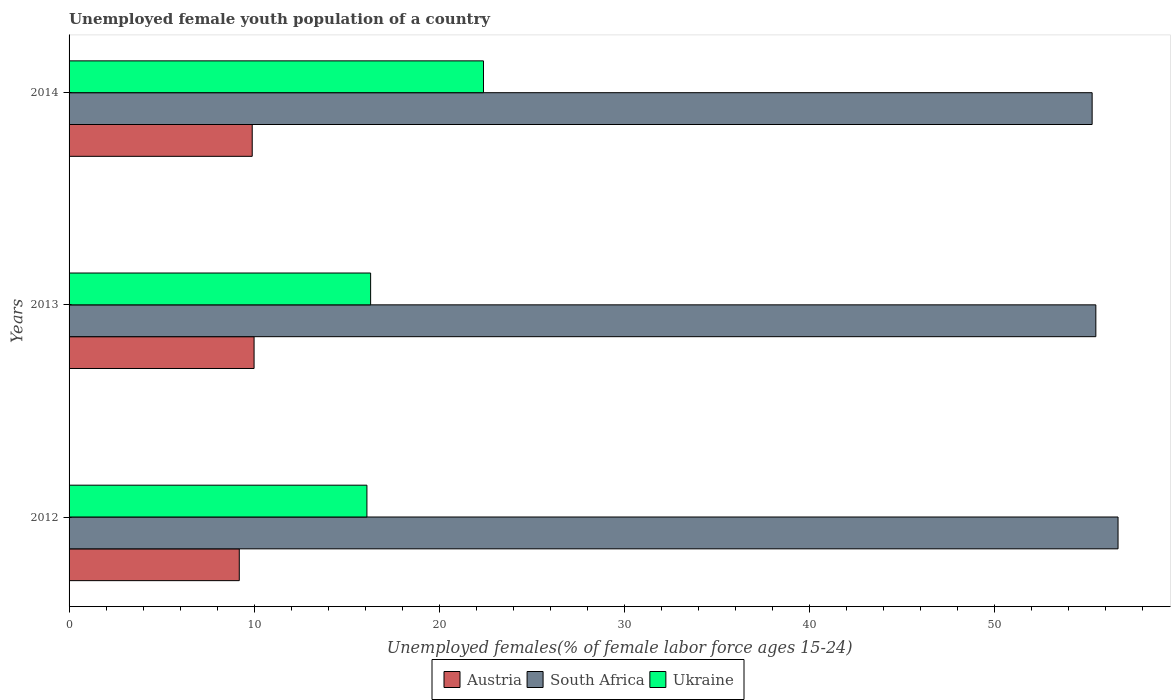Are the number of bars per tick equal to the number of legend labels?
Your answer should be very brief. Yes. Are the number of bars on each tick of the Y-axis equal?
Provide a succinct answer. Yes. What is the label of the 3rd group of bars from the top?
Your answer should be very brief. 2012. What is the percentage of unemployed female youth population in Austria in 2014?
Provide a succinct answer. 9.9. Across all years, what is the maximum percentage of unemployed female youth population in South Africa?
Ensure brevity in your answer.  56.7. Across all years, what is the minimum percentage of unemployed female youth population in Austria?
Keep it short and to the point. 9.2. In which year was the percentage of unemployed female youth population in South Africa minimum?
Your response must be concise. 2014. What is the total percentage of unemployed female youth population in Ukraine in the graph?
Your answer should be very brief. 54.8. What is the difference between the percentage of unemployed female youth population in South Africa in 2012 and that in 2014?
Offer a terse response. 1.4. What is the difference between the percentage of unemployed female youth population in Austria in 2014 and the percentage of unemployed female youth population in Ukraine in 2012?
Ensure brevity in your answer.  -6.2. What is the average percentage of unemployed female youth population in Ukraine per year?
Make the answer very short. 18.27. In the year 2012, what is the difference between the percentage of unemployed female youth population in South Africa and percentage of unemployed female youth population in Austria?
Give a very brief answer. 47.5. What is the ratio of the percentage of unemployed female youth population in Ukraine in 2012 to that in 2013?
Keep it short and to the point. 0.99. Is the percentage of unemployed female youth population in South Africa in 2012 less than that in 2013?
Ensure brevity in your answer.  No. Is the difference between the percentage of unemployed female youth population in South Africa in 2012 and 2013 greater than the difference between the percentage of unemployed female youth population in Austria in 2012 and 2013?
Your answer should be very brief. Yes. What is the difference between the highest and the second highest percentage of unemployed female youth population in Ukraine?
Ensure brevity in your answer.  6.1. What is the difference between the highest and the lowest percentage of unemployed female youth population in South Africa?
Provide a short and direct response. 1.4. In how many years, is the percentage of unemployed female youth population in Ukraine greater than the average percentage of unemployed female youth population in Ukraine taken over all years?
Offer a terse response. 1. Is the sum of the percentage of unemployed female youth population in South Africa in 2012 and 2013 greater than the maximum percentage of unemployed female youth population in Ukraine across all years?
Your answer should be very brief. Yes. What does the 2nd bar from the top in 2013 represents?
Offer a very short reply. South Africa. What does the 1st bar from the bottom in 2012 represents?
Give a very brief answer. Austria. How many bars are there?
Offer a very short reply. 9. Are all the bars in the graph horizontal?
Your response must be concise. Yes. What is the difference between two consecutive major ticks on the X-axis?
Make the answer very short. 10. Are the values on the major ticks of X-axis written in scientific E-notation?
Keep it short and to the point. No. Does the graph contain grids?
Provide a succinct answer. No. How many legend labels are there?
Your response must be concise. 3. How are the legend labels stacked?
Give a very brief answer. Horizontal. What is the title of the graph?
Provide a short and direct response. Unemployed female youth population of a country. What is the label or title of the X-axis?
Offer a terse response. Unemployed females(% of female labor force ages 15-24). What is the label or title of the Y-axis?
Your answer should be very brief. Years. What is the Unemployed females(% of female labor force ages 15-24) of Austria in 2012?
Make the answer very short. 9.2. What is the Unemployed females(% of female labor force ages 15-24) in South Africa in 2012?
Provide a succinct answer. 56.7. What is the Unemployed females(% of female labor force ages 15-24) in Ukraine in 2012?
Your answer should be very brief. 16.1. What is the Unemployed females(% of female labor force ages 15-24) of South Africa in 2013?
Provide a succinct answer. 55.5. What is the Unemployed females(% of female labor force ages 15-24) of Ukraine in 2013?
Provide a short and direct response. 16.3. What is the Unemployed females(% of female labor force ages 15-24) of Austria in 2014?
Make the answer very short. 9.9. What is the Unemployed females(% of female labor force ages 15-24) of South Africa in 2014?
Keep it short and to the point. 55.3. What is the Unemployed females(% of female labor force ages 15-24) in Ukraine in 2014?
Offer a terse response. 22.4. Across all years, what is the maximum Unemployed females(% of female labor force ages 15-24) of South Africa?
Ensure brevity in your answer.  56.7. Across all years, what is the maximum Unemployed females(% of female labor force ages 15-24) of Ukraine?
Provide a short and direct response. 22.4. Across all years, what is the minimum Unemployed females(% of female labor force ages 15-24) of Austria?
Ensure brevity in your answer.  9.2. Across all years, what is the minimum Unemployed females(% of female labor force ages 15-24) of South Africa?
Your response must be concise. 55.3. Across all years, what is the minimum Unemployed females(% of female labor force ages 15-24) of Ukraine?
Offer a very short reply. 16.1. What is the total Unemployed females(% of female labor force ages 15-24) of Austria in the graph?
Your response must be concise. 29.1. What is the total Unemployed females(% of female labor force ages 15-24) in South Africa in the graph?
Your response must be concise. 167.5. What is the total Unemployed females(% of female labor force ages 15-24) of Ukraine in the graph?
Provide a succinct answer. 54.8. What is the difference between the Unemployed females(% of female labor force ages 15-24) in South Africa in 2012 and that in 2013?
Keep it short and to the point. 1.2. What is the difference between the Unemployed females(% of female labor force ages 15-24) in Ukraine in 2012 and that in 2013?
Provide a short and direct response. -0.2. What is the difference between the Unemployed females(% of female labor force ages 15-24) of Ukraine in 2012 and that in 2014?
Make the answer very short. -6.3. What is the difference between the Unemployed females(% of female labor force ages 15-24) of Austria in 2013 and that in 2014?
Ensure brevity in your answer.  0.1. What is the difference between the Unemployed females(% of female labor force ages 15-24) of South Africa in 2013 and that in 2014?
Your response must be concise. 0.2. What is the difference between the Unemployed females(% of female labor force ages 15-24) in Ukraine in 2013 and that in 2014?
Provide a succinct answer. -6.1. What is the difference between the Unemployed females(% of female labor force ages 15-24) in Austria in 2012 and the Unemployed females(% of female labor force ages 15-24) in South Africa in 2013?
Offer a terse response. -46.3. What is the difference between the Unemployed females(% of female labor force ages 15-24) of Austria in 2012 and the Unemployed females(% of female labor force ages 15-24) of Ukraine in 2013?
Your answer should be compact. -7.1. What is the difference between the Unemployed females(% of female labor force ages 15-24) of South Africa in 2012 and the Unemployed females(% of female labor force ages 15-24) of Ukraine in 2013?
Offer a terse response. 40.4. What is the difference between the Unemployed females(% of female labor force ages 15-24) of Austria in 2012 and the Unemployed females(% of female labor force ages 15-24) of South Africa in 2014?
Keep it short and to the point. -46.1. What is the difference between the Unemployed females(% of female labor force ages 15-24) in South Africa in 2012 and the Unemployed females(% of female labor force ages 15-24) in Ukraine in 2014?
Make the answer very short. 34.3. What is the difference between the Unemployed females(% of female labor force ages 15-24) of Austria in 2013 and the Unemployed females(% of female labor force ages 15-24) of South Africa in 2014?
Ensure brevity in your answer.  -45.3. What is the difference between the Unemployed females(% of female labor force ages 15-24) of South Africa in 2013 and the Unemployed females(% of female labor force ages 15-24) of Ukraine in 2014?
Give a very brief answer. 33.1. What is the average Unemployed females(% of female labor force ages 15-24) in Austria per year?
Offer a very short reply. 9.7. What is the average Unemployed females(% of female labor force ages 15-24) in South Africa per year?
Your answer should be compact. 55.83. What is the average Unemployed females(% of female labor force ages 15-24) in Ukraine per year?
Ensure brevity in your answer.  18.27. In the year 2012, what is the difference between the Unemployed females(% of female labor force ages 15-24) in Austria and Unemployed females(% of female labor force ages 15-24) in South Africa?
Offer a very short reply. -47.5. In the year 2012, what is the difference between the Unemployed females(% of female labor force ages 15-24) in South Africa and Unemployed females(% of female labor force ages 15-24) in Ukraine?
Your answer should be very brief. 40.6. In the year 2013, what is the difference between the Unemployed females(% of female labor force ages 15-24) of Austria and Unemployed females(% of female labor force ages 15-24) of South Africa?
Give a very brief answer. -45.5. In the year 2013, what is the difference between the Unemployed females(% of female labor force ages 15-24) in Austria and Unemployed females(% of female labor force ages 15-24) in Ukraine?
Keep it short and to the point. -6.3. In the year 2013, what is the difference between the Unemployed females(% of female labor force ages 15-24) in South Africa and Unemployed females(% of female labor force ages 15-24) in Ukraine?
Provide a short and direct response. 39.2. In the year 2014, what is the difference between the Unemployed females(% of female labor force ages 15-24) in Austria and Unemployed females(% of female labor force ages 15-24) in South Africa?
Your answer should be very brief. -45.4. In the year 2014, what is the difference between the Unemployed females(% of female labor force ages 15-24) in Austria and Unemployed females(% of female labor force ages 15-24) in Ukraine?
Make the answer very short. -12.5. In the year 2014, what is the difference between the Unemployed females(% of female labor force ages 15-24) of South Africa and Unemployed females(% of female labor force ages 15-24) of Ukraine?
Offer a very short reply. 32.9. What is the ratio of the Unemployed females(% of female labor force ages 15-24) in South Africa in 2012 to that in 2013?
Keep it short and to the point. 1.02. What is the ratio of the Unemployed females(% of female labor force ages 15-24) of Ukraine in 2012 to that in 2013?
Your answer should be very brief. 0.99. What is the ratio of the Unemployed females(% of female labor force ages 15-24) in Austria in 2012 to that in 2014?
Provide a succinct answer. 0.93. What is the ratio of the Unemployed females(% of female labor force ages 15-24) of South Africa in 2012 to that in 2014?
Offer a terse response. 1.03. What is the ratio of the Unemployed females(% of female labor force ages 15-24) of Ukraine in 2012 to that in 2014?
Offer a terse response. 0.72. What is the ratio of the Unemployed females(% of female labor force ages 15-24) of South Africa in 2013 to that in 2014?
Offer a terse response. 1. What is the ratio of the Unemployed females(% of female labor force ages 15-24) in Ukraine in 2013 to that in 2014?
Your response must be concise. 0.73. What is the difference between the highest and the second highest Unemployed females(% of female labor force ages 15-24) of Austria?
Provide a succinct answer. 0.1. What is the difference between the highest and the lowest Unemployed females(% of female labor force ages 15-24) in Ukraine?
Provide a short and direct response. 6.3. 